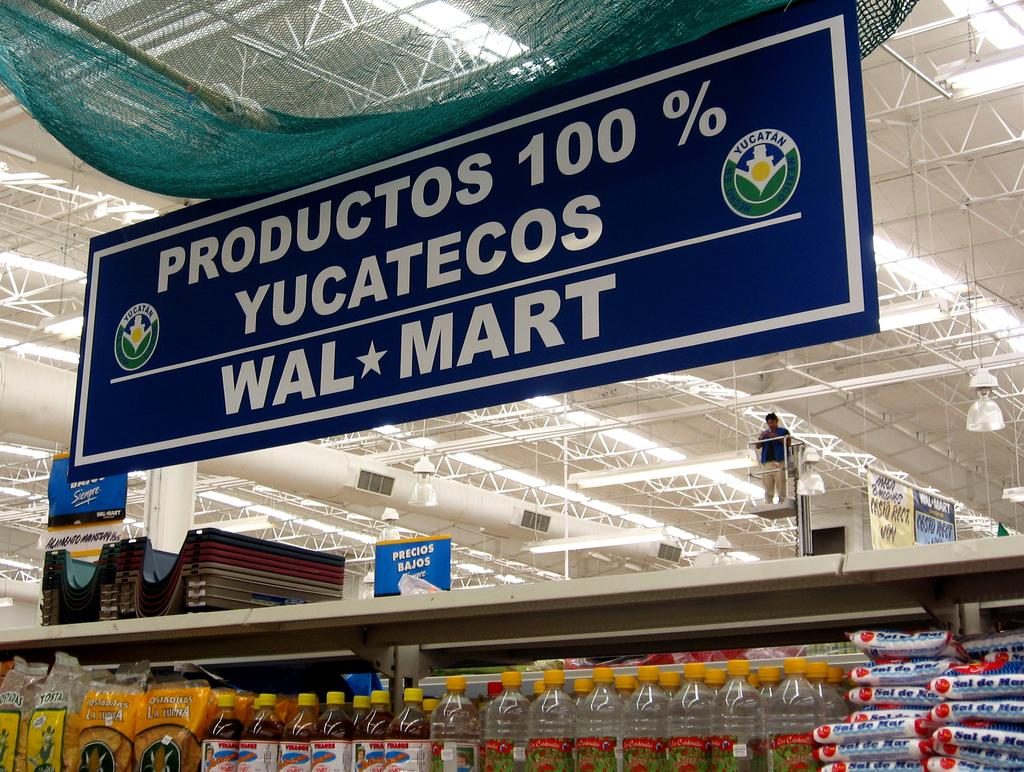<image>
Give a short and clear explanation of the subsequent image. A spanish speaking walmart display sign in the food section. 